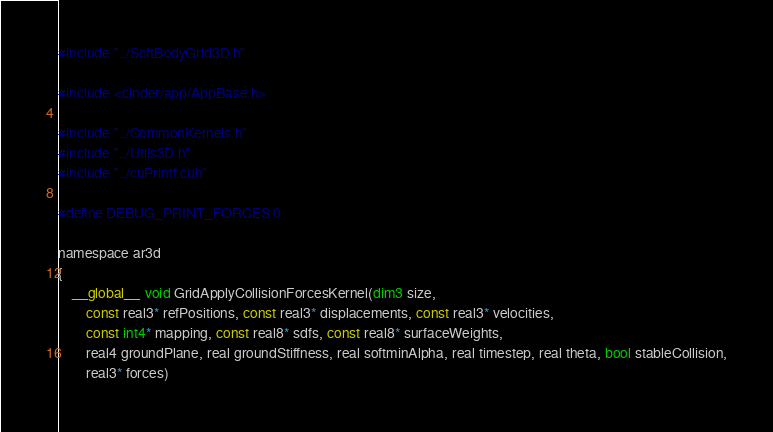<code> <loc_0><loc_0><loc_500><loc_500><_Cuda_>#include "../SoftBodyGrid3D.h"

#include <cinder/app/AppBase.h>

#include "../CommonKernels.h"
#include "../Utils3D.h"
#include "../cuPrintf.cuh"

#define DEBUG_PRINT_FORCES 0

namespace ar3d
{
	__global__ void GridApplyCollisionForcesKernel(dim3 size,
		const real3* refPositions, const real3* displacements, const real3* velocities, 
		const int4* mapping, const real8* sdfs, const real8* surfaceWeights,
		real4 groundPlane, real groundStiffness, real softminAlpha, real timestep, real theta, bool stableCollision,
		real3* forces)</code> 